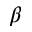<formula> <loc_0><loc_0><loc_500><loc_500>\beta</formula> 